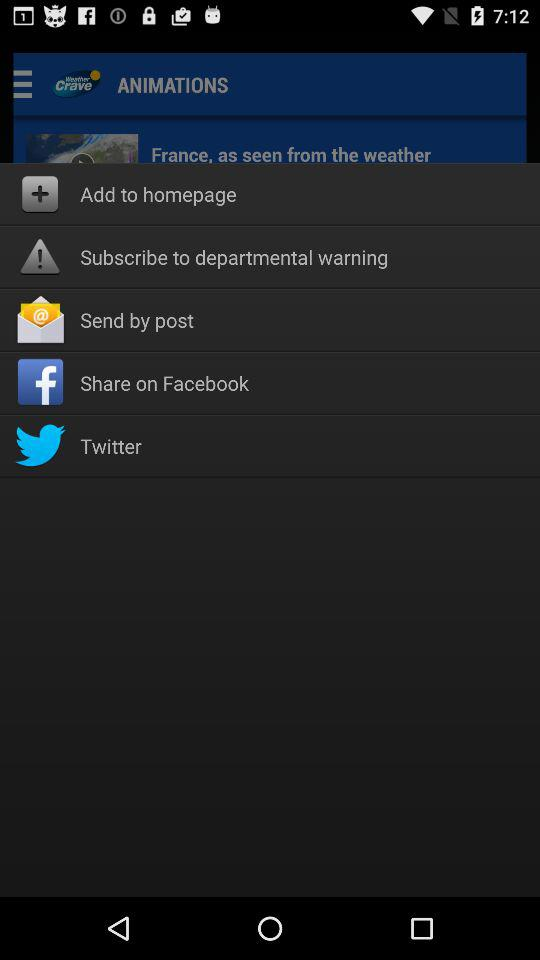Who is this application powered by?
When the provided information is insufficient, respond with <no answer>. <no answer> 